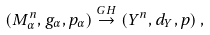Convert formula to latex. <formula><loc_0><loc_0><loc_500><loc_500>( M ^ { n } _ { \alpha } , g _ { \alpha } , p _ { \alpha } ) \stackrel { G H } { \rightarrow } ( Y ^ { n } , d _ { Y } , p ) \, ,</formula> 